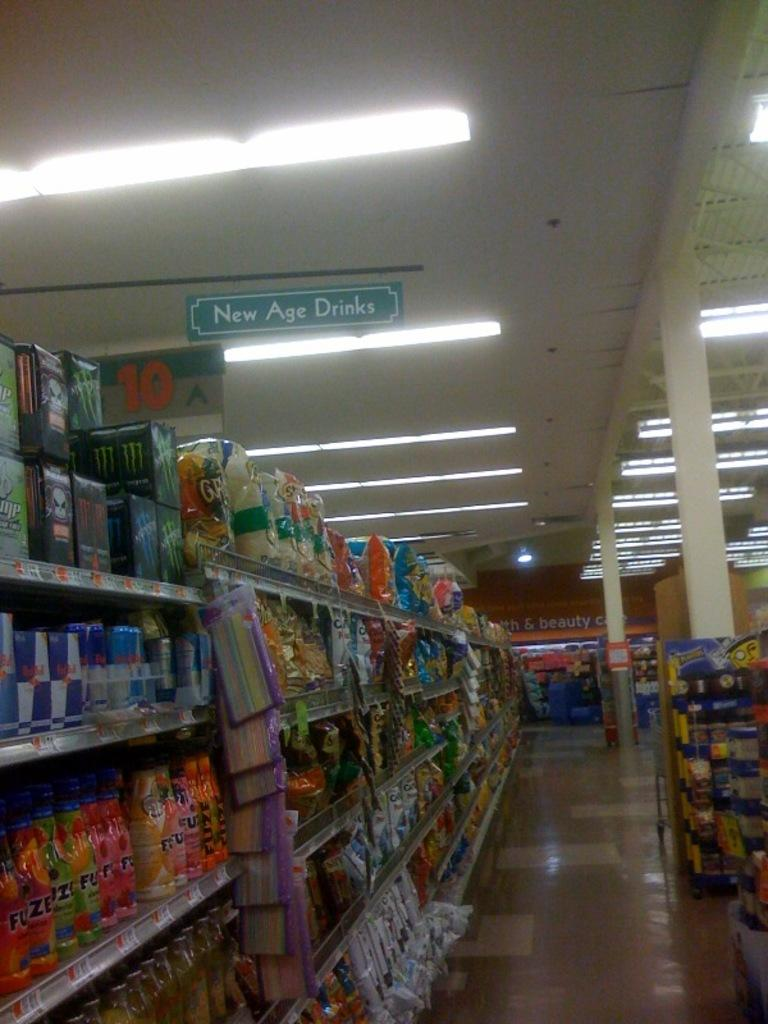<image>
Create a compact narrative representing the image presented. An aisle in a grocery store advertising New Age Drinks. 